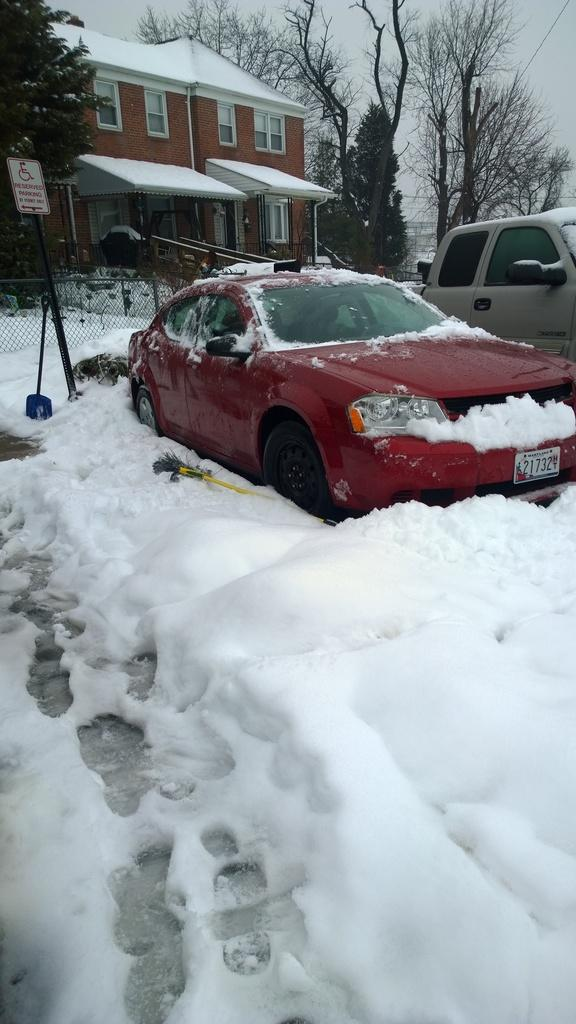What type of structure is present in the image? There is a building in the image. What is the condition of the ground in the image? The ground is covered in snow, and there are cars on the snow floor. What type of vegetation can be seen in the image? There are trees around the area. How many cars can be seen in the image? There are additional cars visible in the image, in addition to the ones on the snow floor. What type of tin is being used to solve arithmetic problems in the image? There is no tin or arithmetic problems present in the image. 